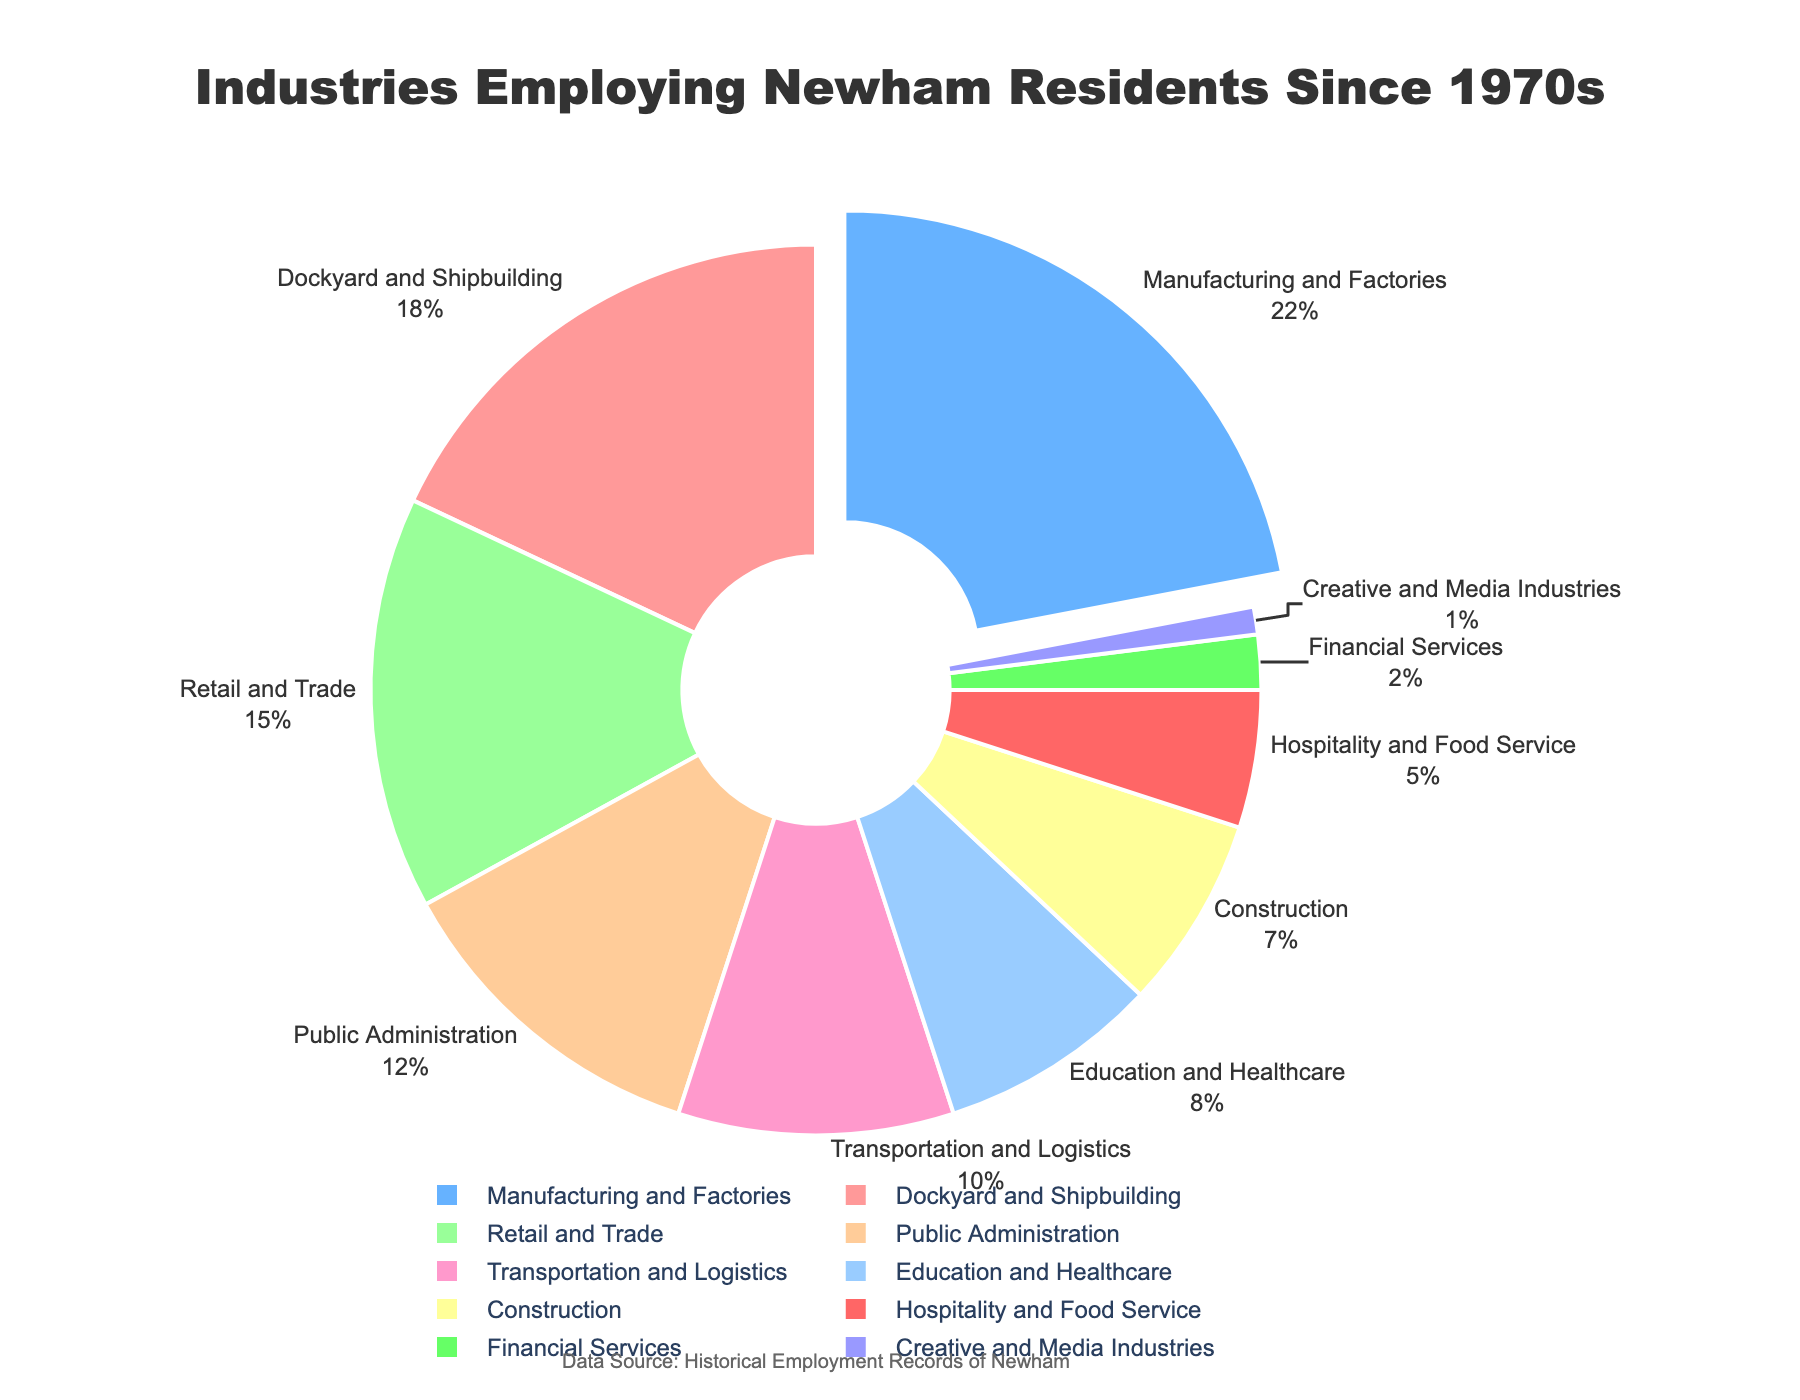What percentage of Newham residents have been employed in Manufacturing and Factories? Locate the section of the pie chart labeled "Manufacturing and Factories" and read its associated percentage.
Answer: 22% Which industry employs the fewest Newham residents? Find the smallest slice in the pie chart and read the label attached to it.
Answer: Creative and Media Industries What is the combined percentage of residents employed in Retail and Trade, and Public Administration? Identify the slices labeled "Retail and Trade" and "Public Administration." Add their percentages together.
Answer: 15% + 12% = 27% Which industry has the largest slice in the pie chart and what is its percentage? Locate the largest slice of the pie chart and identify its label and percentage.
Answer: Manufacturing and Factories, 22% Are more residents employed in Education and Healthcare or in Transportation and Logistics? Compare the percentages of the slices labeled "Education and Healthcare" and "Transportation and Logistics."
Answer: Transportation and Logistics What are the total percentages of residents employed in the top three industries? Identify the slices with the three largest percentages and add them together.
Answer: 22% + 18% + 15% = 55% Which industries employ exactly 5% and 2% of Newham residents, respectively? Locate the slices with percentages 5% and 2% and read their labels.
Answer: Hospitality and Food Service, Financial Services What is the difference between the percentages of residents employed in Construction and in Public Administration? Subtract the percentage of the slice labeled "Construction" from that of "Public Administration."
Answer: 12% - 7% = 5% What is the percentage of residents employed in Creative and Media Industries plus Financial Services? Add the percentages of the slices labeled "Creative and Media Industries" and "Financial Services."
Answer: 1% + 2% = 3% Which industry is represented by a blue slice, and what is its percentage? Find the slice colored blue and identify its label and percentage.
Answer: Manufacturing and Factories, 22% 